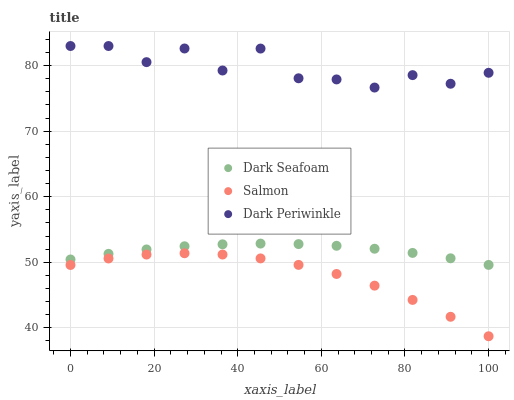Does Salmon have the minimum area under the curve?
Answer yes or no. Yes. Does Dark Periwinkle have the maximum area under the curve?
Answer yes or no. Yes. Does Dark Periwinkle have the minimum area under the curve?
Answer yes or no. No. Does Salmon have the maximum area under the curve?
Answer yes or no. No. Is Dark Seafoam the smoothest?
Answer yes or no. Yes. Is Dark Periwinkle the roughest?
Answer yes or no. Yes. Is Salmon the smoothest?
Answer yes or no. No. Is Salmon the roughest?
Answer yes or no. No. Does Salmon have the lowest value?
Answer yes or no. Yes. Does Dark Periwinkle have the lowest value?
Answer yes or no. No. Does Dark Periwinkle have the highest value?
Answer yes or no. Yes. Does Salmon have the highest value?
Answer yes or no. No. Is Dark Seafoam less than Dark Periwinkle?
Answer yes or no. Yes. Is Dark Seafoam greater than Salmon?
Answer yes or no. Yes. Does Dark Seafoam intersect Dark Periwinkle?
Answer yes or no. No. 